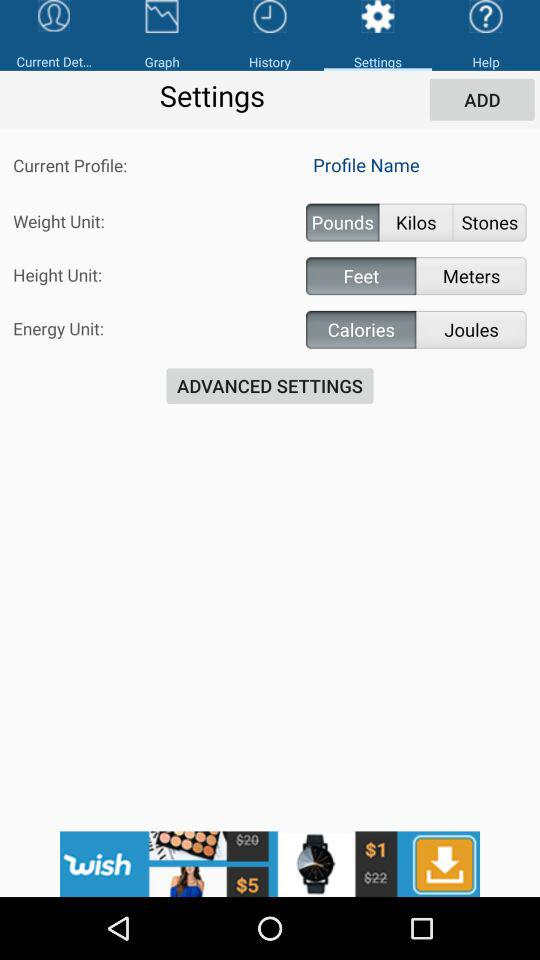How many weight units are available?
Answer the question using a single word or phrase. 3 